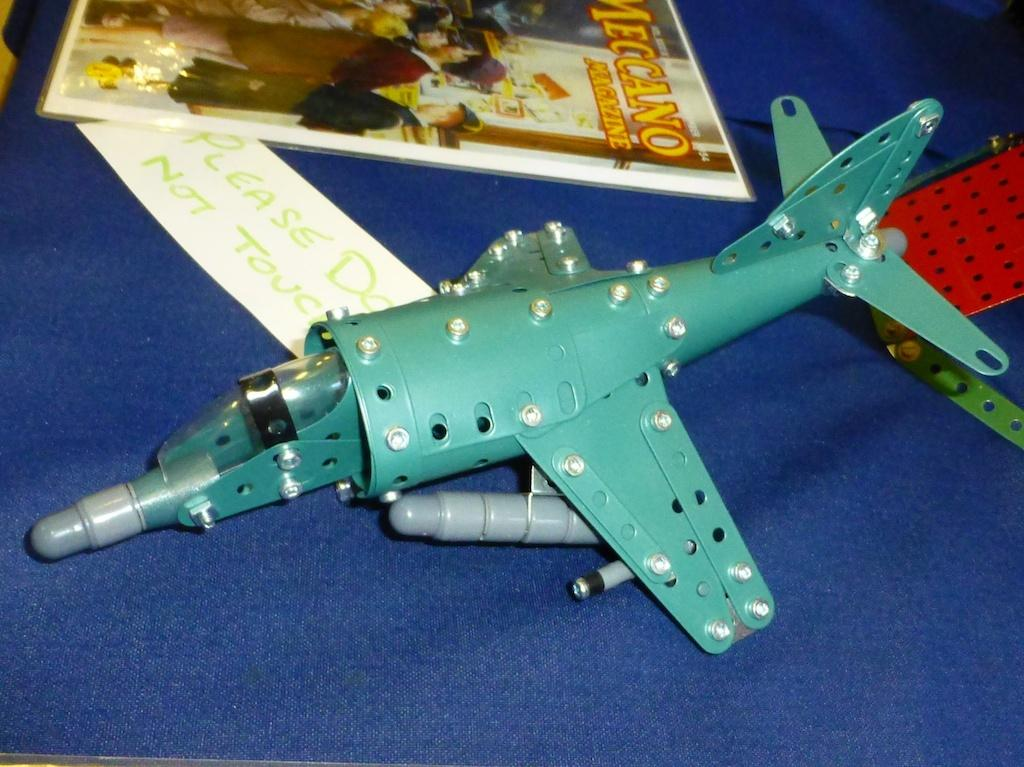<image>
Provide a brief description of the given image. A toy Construx plane sits next to a handwritten note imploring Please Do Not Touch. 